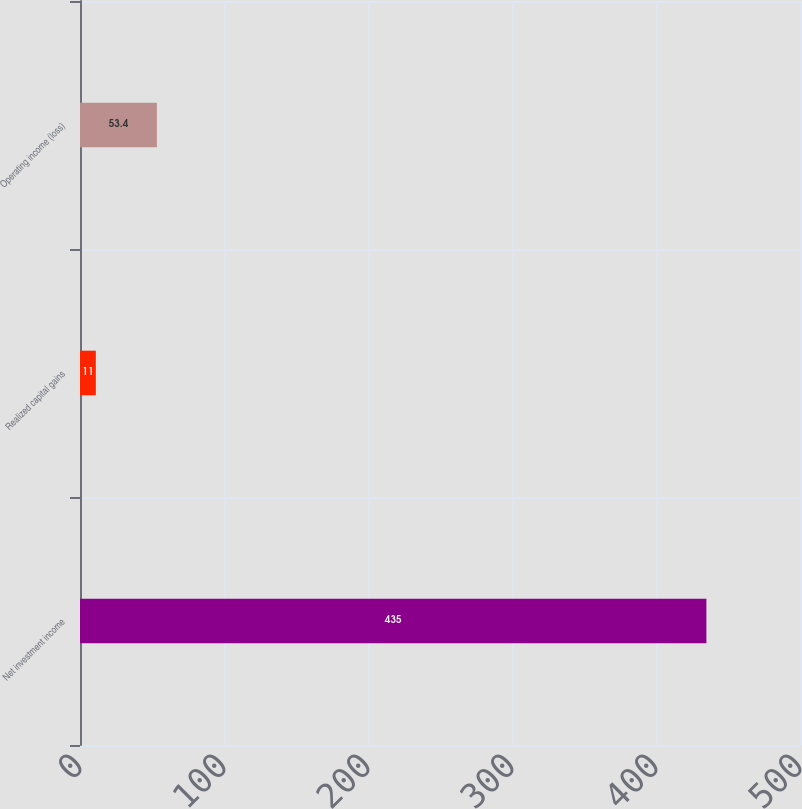Convert chart. <chart><loc_0><loc_0><loc_500><loc_500><bar_chart><fcel>Net investment income<fcel>Realized capital gains<fcel>Operating income (loss)<nl><fcel>435<fcel>11<fcel>53.4<nl></chart> 